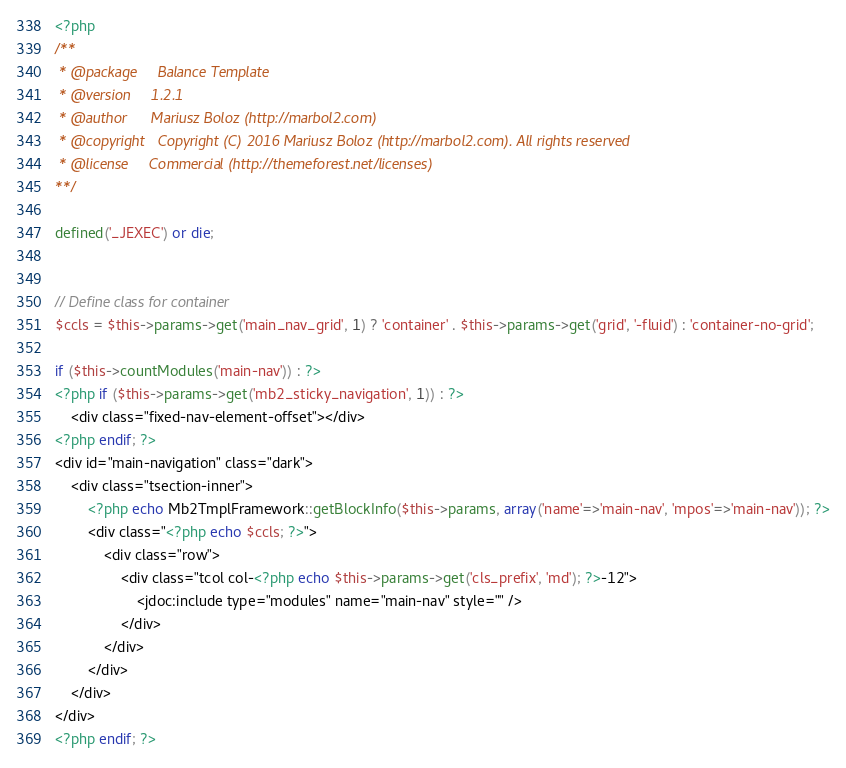Convert code to text. <code><loc_0><loc_0><loc_500><loc_500><_PHP_><?php
/**
 * @package		Balance Template
 * @version		1.2.1
 * @author		Mariusz Boloz (http://marbol2.com)
 * @copyright	Copyright (C) 2016 Mariusz Boloz (http://marbol2.com). All rights reserved
 * @license		Commercial (http://themeforest.net/licenses)
**/ 

defined('_JEXEC') or die;


// Define class for container
$ccls = $this->params->get('main_nav_grid', 1) ? 'container' . $this->params->get('grid', '-fluid') : 'container-no-grid';	

if ($this->countModules('main-nav')) : ?>
<?php if ($this->params->get('mb2_sticky_navigation', 1)) : ?>
	<div class="fixed-nav-element-offset"></div>
<?php endif; ?>
<div id="main-navigation" class="dark">
	<div class="tsection-inner">
		<?php echo Mb2TmplFramework::getBlockInfo($this->params, array('name'=>'main-nav', 'mpos'=>'main-nav')); ?>
        <div class="<?php echo $ccls; ?>">	
            <div class="row">												
                <div class="tcol col-<?php echo $this->params->get('cls_prefix', 'md'); ?>-12">
                    <jdoc:include type="modules" name="main-nav" style="" />
                </div>	
            </div>	        
        </div>
    </div>	  
</div>
<?php endif; ?></code> 